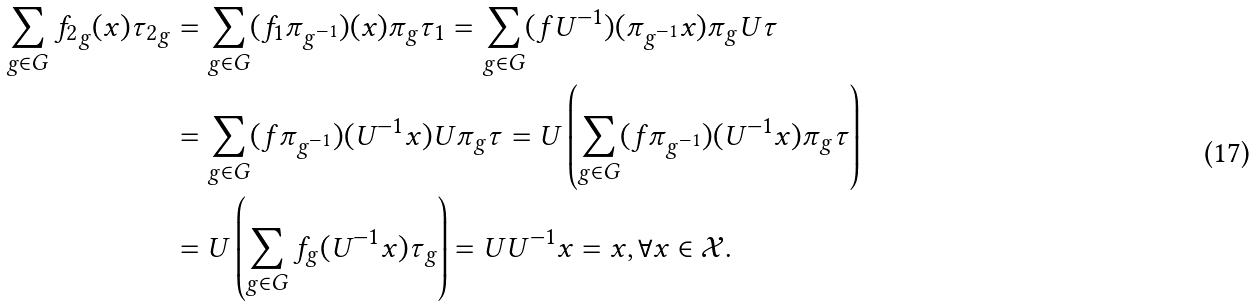Convert formula to latex. <formula><loc_0><loc_0><loc_500><loc_500>\sum _ { g \in G } { f _ { 2 } } _ { g } ( x ) { \tau _ { 2 } } _ { g } & = \sum _ { g \in G } ( f _ { 1 } \pi _ { g ^ { - 1 } } ) ( x ) \pi _ { g } \tau _ { 1 } = \sum _ { g \in G } ( f U ^ { - 1 } ) ( \pi _ { g ^ { - 1 } } x ) \pi _ { g } U \tau \\ & = \sum _ { g \in G } ( f \pi _ { g ^ { - 1 } } ) ( U ^ { - 1 } x ) U \pi _ { g } \tau = U \left ( \sum _ { g \in G } ( f \pi _ { g ^ { - 1 } } ) ( U ^ { - 1 } x ) \pi _ { g } \tau \right ) \\ & = U \left ( \sum _ { g \in G } f _ { g } ( U ^ { - 1 } x ) \tau _ { g } \right ) = U U ^ { - 1 } x = x , \forall x \in \mathcal { X } .</formula> 